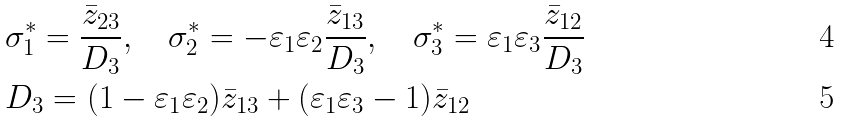Convert formula to latex. <formula><loc_0><loc_0><loc_500><loc_500>& \sigma _ { 1 } ^ { * } = \frac { \bar { z } _ { 2 3 } } { D _ { 3 } } , \quad \sigma _ { 2 } ^ { * } = - \varepsilon _ { 1 } \varepsilon _ { 2 } \frac { \bar { z } _ { 1 3 } } { D _ { 3 } } , \quad \sigma _ { 3 } ^ { * } = \varepsilon _ { 1 } \varepsilon _ { 3 } \frac { \bar { z } _ { 1 2 } } { D _ { 3 } } \\ & D _ { 3 } = ( 1 - \varepsilon _ { 1 } \varepsilon _ { 2 } ) \bar { z } _ { 1 3 } + ( \varepsilon _ { 1 } \varepsilon _ { 3 } - 1 ) \bar { z } _ { 1 2 }</formula> 